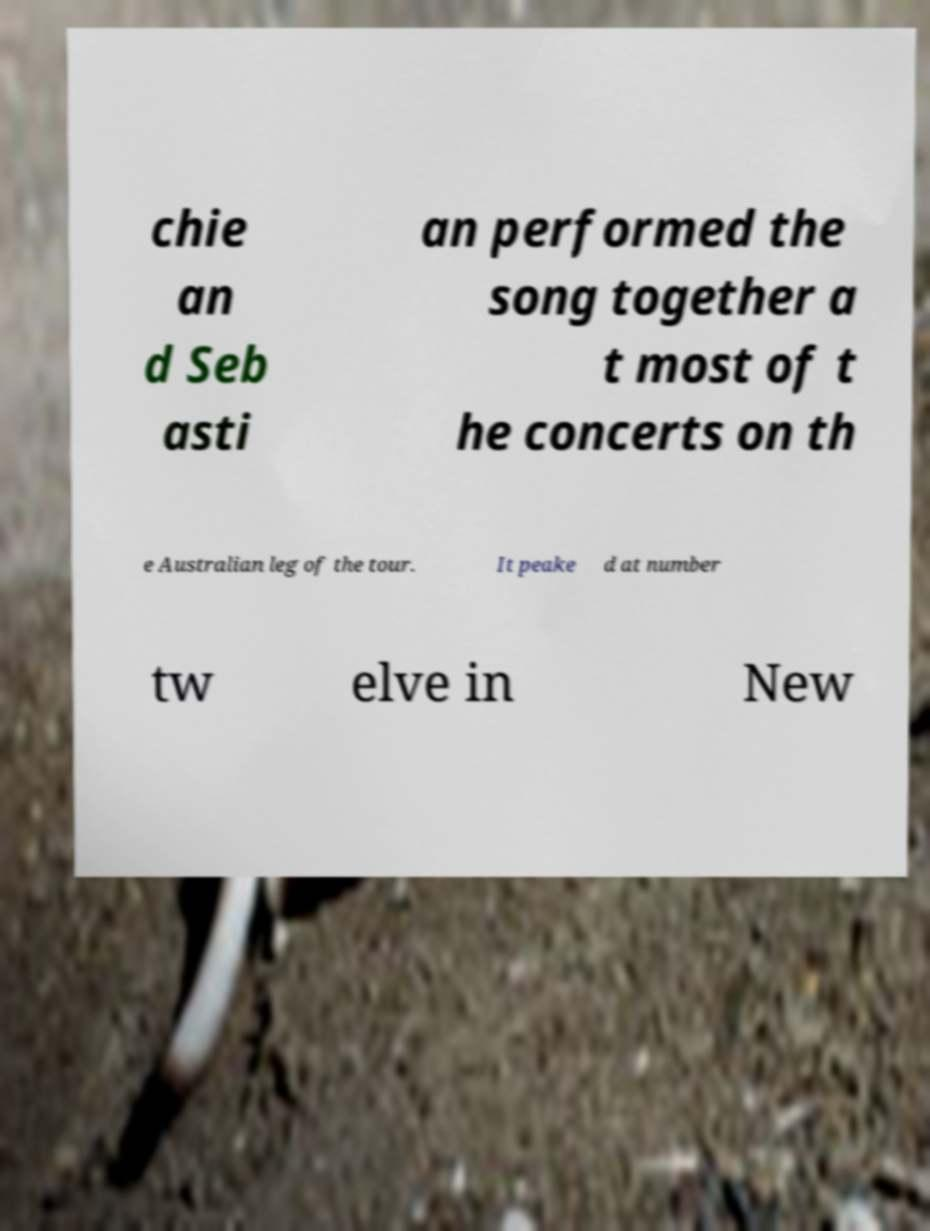What messages or text are displayed in this image? I need them in a readable, typed format. chie an d Seb asti an performed the song together a t most of t he concerts on th e Australian leg of the tour. It peake d at number tw elve in New 